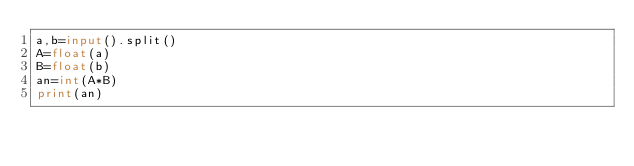Convert code to text. <code><loc_0><loc_0><loc_500><loc_500><_Python_>a,b=input().split()
A=float(a)
B=float(b)
an=int(A*B)
print(an)
</code> 